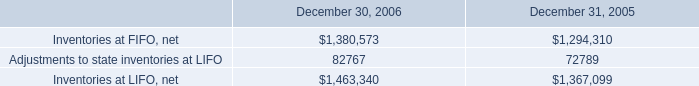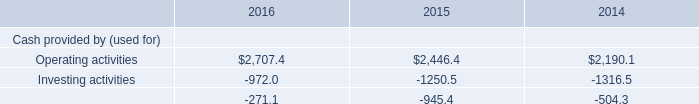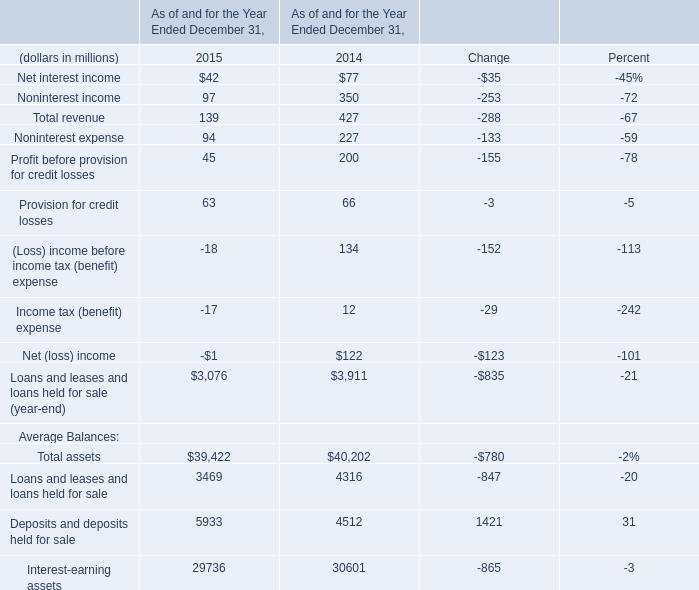Does Deposits and deposits held for sale keeps increasing each year between 2015 and 2014? 
Answer: Yes. 